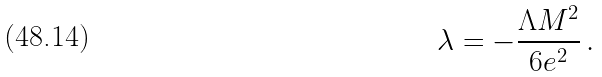Convert formula to latex. <formula><loc_0><loc_0><loc_500><loc_500>\lambda = - \frac { \Lambda M ^ { 2 } } { 6 e ^ { 2 } } \, .</formula> 